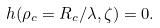Convert formula to latex. <formula><loc_0><loc_0><loc_500><loc_500>h ( \rho _ { c } = R _ { c } / \lambda , \zeta ) = 0 .</formula> 